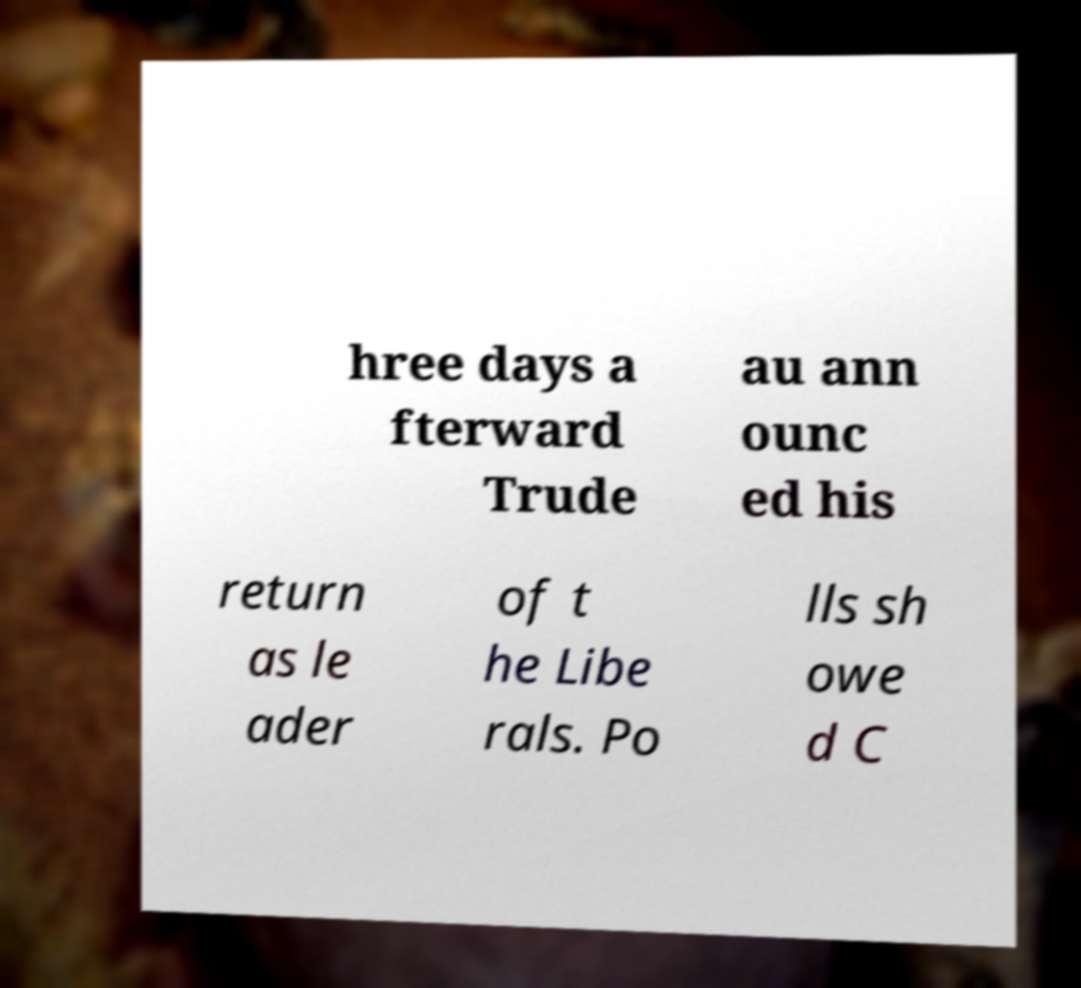There's text embedded in this image that I need extracted. Can you transcribe it verbatim? hree days a fterward Trude au ann ounc ed his return as le ader of t he Libe rals. Po lls sh owe d C 